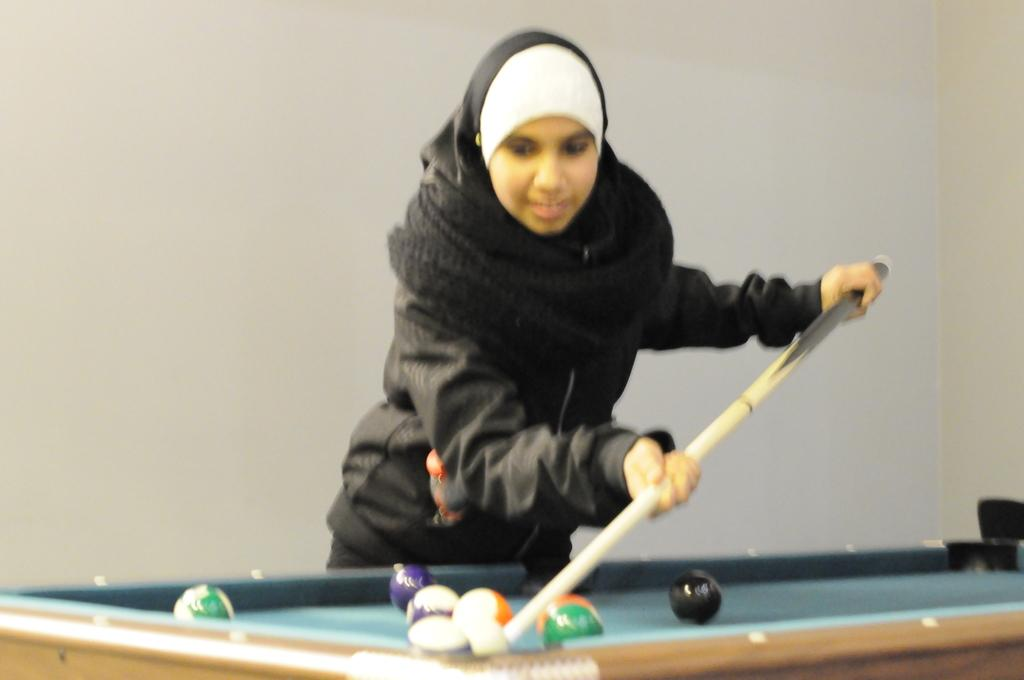What is the woman doing in the image? The woman is standing in the image. What is the woman holding in her hand? The woman is holding a stick in her hand. What is in front of the woman? There is a billiards table in front of the woman. What is behind the woman? There is a wall behind the woman. What type of beast can be seen attacking the woman in the image? There is no beast present in the image; the woman is simply standing with a stick in her hand. 